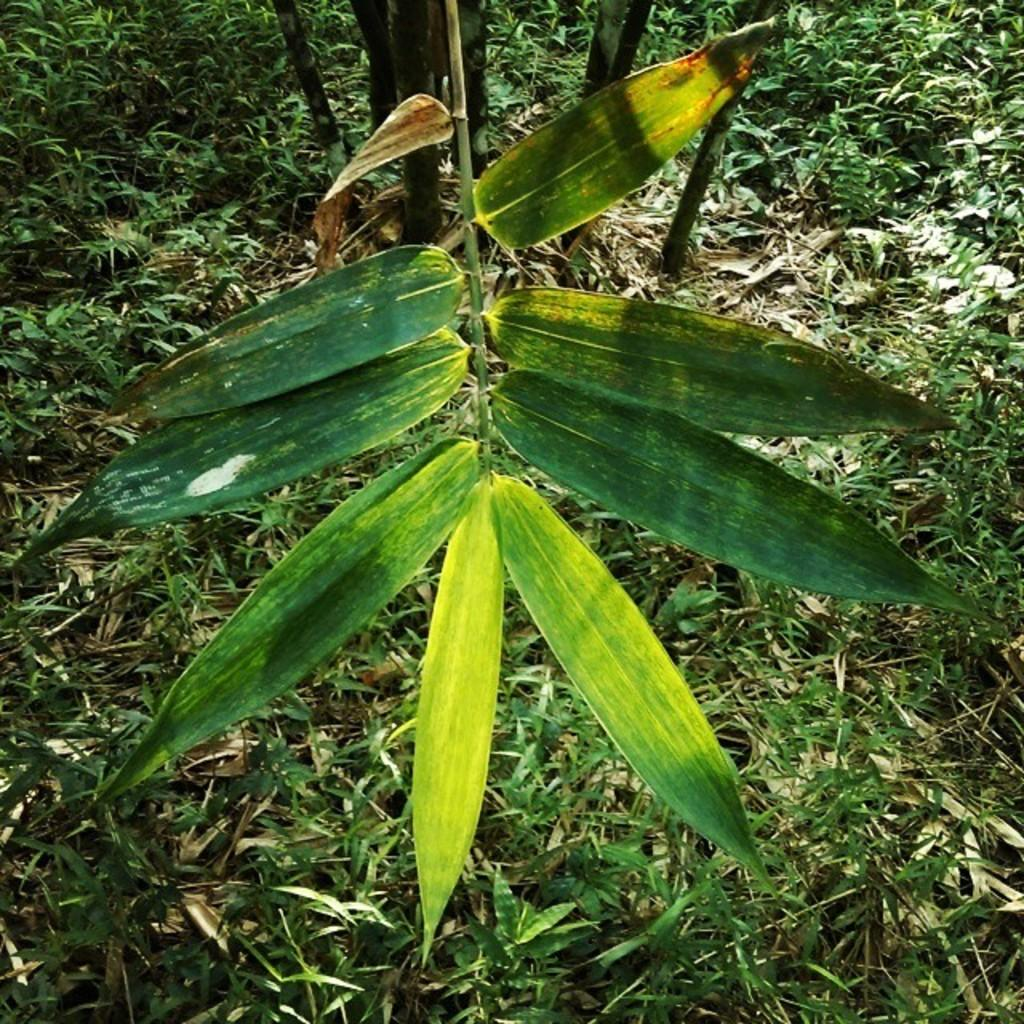What type of surface is visible in the image? The image contains a grass surface. What else can be seen on the grass surface? There is a part of a plant visible on the grass surface. Can you describe the plant in the image? The plant has long leaves. What type of potato is growing on the grass surface in the image? There is no potato present in the image; it features a plant with long leaves. Can you tell me how many balloons are tied to the plant in the image? There are no balloons present in the image; it only features a plant with long leaves on a grass surface. 